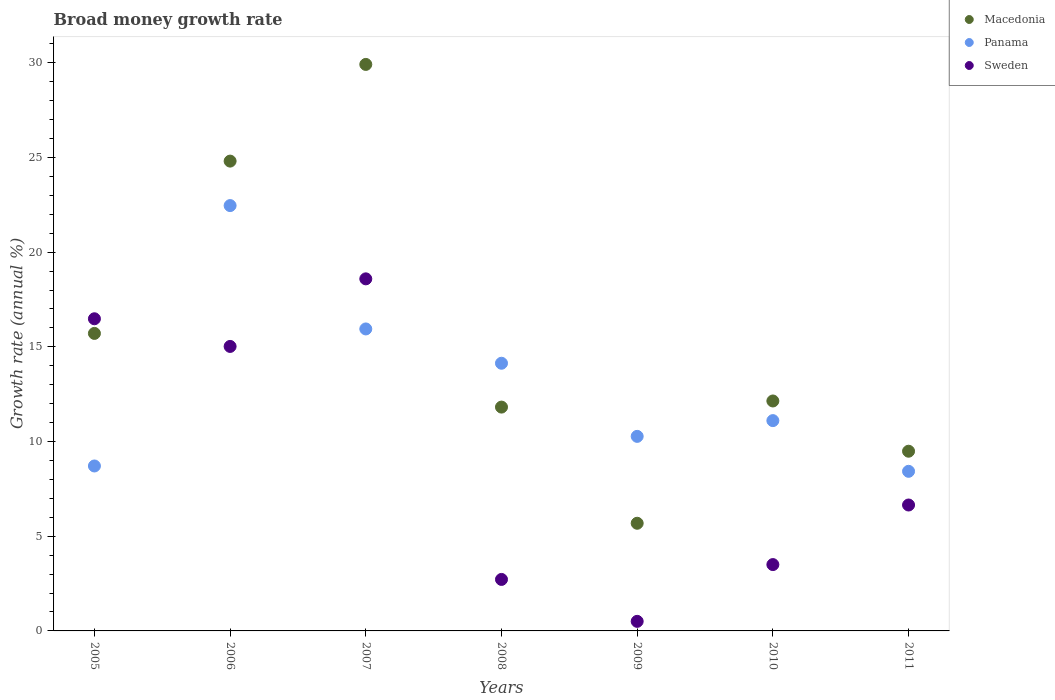How many different coloured dotlines are there?
Your response must be concise. 3. What is the growth rate in Panama in 2010?
Provide a succinct answer. 11.1. Across all years, what is the maximum growth rate in Macedonia?
Provide a succinct answer. 29.91. Across all years, what is the minimum growth rate in Sweden?
Offer a terse response. 0.51. In which year was the growth rate in Panama maximum?
Give a very brief answer. 2006. What is the total growth rate in Sweden in the graph?
Provide a succinct answer. 63.47. What is the difference between the growth rate in Sweden in 2005 and that in 2010?
Offer a very short reply. 12.98. What is the difference between the growth rate in Sweden in 2006 and the growth rate in Macedonia in 2010?
Offer a terse response. 2.88. What is the average growth rate in Macedonia per year?
Make the answer very short. 15.65. In the year 2008, what is the difference between the growth rate in Panama and growth rate in Macedonia?
Provide a succinct answer. 2.32. In how many years, is the growth rate in Panama greater than 5 %?
Ensure brevity in your answer.  7. What is the ratio of the growth rate in Sweden in 2005 to that in 2008?
Offer a terse response. 6.06. Is the difference between the growth rate in Panama in 2010 and 2011 greater than the difference between the growth rate in Macedonia in 2010 and 2011?
Your answer should be very brief. Yes. What is the difference between the highest and the second highest growth rate in Macedonia?
Ensure brevity in your answer.  5.11. What is the difference between the highest and the lowest growth rate in Sweden?
Offer a terse response. 18.08. In how many years, is the growth rate in Macedonia greater than the average growth rate in Macedonia taken over all years?
Your answer should be compact. 3. Is the sum of the growth rate in Panama in 2005 and 2011 greater than the maximum growth rate in Macedonia across all years?
Make the answer very short. No. Is the growth rate in Panama strictly less than the growth rate in Macedonia over the years?
Your answer should be very brief. No. What is the difference between two consecutive major ticks on the Y-axis?
Your response must be concise. 5. Are the values on the major ticks of Y-axis written in scientific E-notation?
Make the answer very short. No. Does the graph contain any zero values?
Keep it short and to the point. No. Does the graph contain grids?
Provide a succinct answer. No. What is the title of the graph?
Offer a terse response. Broad money growth rate. Does "Portugal" appear as one of the legend labels in the graph?
Your answer should be compact. No. What is the label or title of the X-axis?
Provide a succinct answer. Years. What is the label or title of the Y-axis?
Make the answer very short. Growth rate (annual %). What is the Growth rate (annual %) of Macedonia in 2005?
Keep it short and to the point. 15.71. What is the Growth rate (annual %) of Panama in 2005?
Ensure brevity in your answer.  8.71. What is the Growth rate (annual %) of Sweden in 2005?
Keep it short and to the point. 16.48. What is the Growth rate (annual %) of Macedonia in 2006?
Give a very brief answer. 24.81. What is the Growth rate (annual %) of Panama in 2006?
Offer a very short reply. 22.46. What is the Growth rate (annual %) of Sweden in 2006?
Make the answer very short. 15.02. What is the Growth rate (annual %) in Macedonia in 2007?
Offer a very short reply. 29.91. What is the Growth rate (annual %) of Panama in 2007?
Your answer should be compact. 15.95. What is the Growth rate (annual %) of Sweden in 2007?
Ensure brevity in your answer.  18.59. What is the Growth rate (annual %) of Macedonia in 2008?
Your answer should be compact. 11.82. What is the Growth rate (annual %) in Panama in 2008?
Offer a terse response. 14.13. What is the Growth rate (annual %) in Sweden in 2008?
Provide a short and direct response. 2.72. What is the Growth rate (annual %) in Macedonia in 2009?
Give a very brief answer. 5.68. What is the Growth rate (annual %) of Panama in 2009?
Offer a terse response. 10.27. What is the Growth rate (annual %) in Sweden in 2009?
Your answer should be compact. 0.51. What is the Growth rate (annual %) in Macedonia in 2010?
Offer a very short reply. 12.14. What is the Growth rate (annual %) of Panama in 2010?
Offer a very short reply. 11.1. What is the Growth rate (annual %) in Sweden in 2010?
Your answer should be compact. 3.5. What is the Growth rate (annual %) in Macedonia in 2011?
Ensure brevity in your answer.  9.49. What is the Growth rate (annual %) of Panama in 2011?
Provide a short and direct response. 8.43. What is the Growth rate (annual %) in Sweden in 2011?
Your response must be concise. 6.65. Across all years, what is the maximum Growth rate (annual %) of Macedonia?
Offer a very short reply. 29.91. Across all years, what is the maximum Growth rate (annual %) of Panama?
Keep it short and to the point. 22.46. Across all years, what is the maximum Growth rate (annual %) of Sweden?
Ensure brevity in your answer.  18.59. Across all years, what is the minimum Growth rate (annual %) in Macedonia?
Your answer should be compact. 5.68. Across all years, what is the minimum Growth rate (annual %) of Panama?
Your response must be concise. 8.43. Across all years, what is the minimum Growth rate (annual %) of Sweden?
Provide a succinct answer. 0.51. What is the total Growth rate (annual %) in Macedonia in the graph?
Your response must be concise. 109.56. What is the total Growth rate (annual %) of Panama in the graph?
Your response must be concise. 91.05. What is the total Growth rate (annual %) of Sweden in the graph?
Your response must be concise. 63.47. What is the difference between the Growth rate (annual %) of Macedonia in 2005 and that in 2006?
Ensure brevity in your answer.  -9.1. What is the difference between the Growth rate (annual %) of Panama in 2005 and that in 2006?
Give a very brief answer. -13.75. What is the difference between the Growth rate (annual %) in Sweden in 2005 and that in 2006?
Offer a terse response. 1.46. What is the difference between the Growth rate (annual %) in Macedonia in 2005 and that in 2007?
Provide a succinct answer. -14.2. What is the difference between the Growth rate (annual %) in Panama in 2005 and that in 2007?
Your answer should be compact. -7.24. What is the difference between the Growth rate (annual %) in Sweden in 2005 and that in 2007?
Provide a succinct answer. -2.11. What is the difference between the Growth rate (annual %) in Macedonia in 2005 and that in 2008?
Make the answer very short. 3.89. What is the difference between the Growth rate (annual %) of Panama in 2005 and that in 2008?
Offer a very short reply. -5.42. What is the difference between the Growth rate (annual %) in Sweden in 2005 and that in 2008?
Give a very brief answer. 13.76. What is the difference between the Growth rate (annual %) of Macedonia in 2005 and that in 2009?
Give a very brief answer. 10.02. What is the difference between the Growth rate (annual %) in Panama in 2005 and that in 2009?
Provide a succinct answer. -1.56. What is the difference between the Growth rate (annual %) in Sweden in 2005 and that in 2009?
Your answer should be very brief. 15.98. What is the difference between the Growth rate (annual %) of Macedonia in 2005 and that in 2010?
Make the answer very short. 3.57. What is the difference between the Growth rate (annual %) of Panama in 2005 and that in 2010?
Offer a terse response. -2.39. What is the difference between the Growth rate (annual %) of Sweden in 2005 and that in 2010?
Keep it short and to the point. 12.98. What is the difference between the Growth rate (annual %) in Macedonia in 2005 and that in 2011?
Your answer should be compact. 6.22. What is the difference between the Growth rate (annual %) in Panama in 2005 and that in 2011?
Provide a short and direct response. 0.28. What is the difference between the Growth rate (annual %) in Sweden in 2005 and that in 2011?
Make the answer very short. 9.83. What is the difference between the Growth rate (annual %) of Macedonia in 2006 and that in 2007?
Your answer should be very brief. -5.11. What is the difference between the Growth rate (annual %) in Panama in 2006 and that in 2007?
Your response must be concise. 6.51. What is the difference between the Growth rate (annual %) of Sweden in 2006 and that in 2007?
Provide a succinct answer. -3.57. What is the difference between the Growth rate (annual %) in Macedonia in 2006 and that in 2008?
Your answer should be compact. 12.99. What is the difference between the Growth rate (annual %) of Panama in 2006 and that in 2008?
Offer a very short reply. 8.32. What is the difference between the Growth rate (annual %) in Sweden in 2006 and that in 2008?
Your answer should be very brief. 12.3. What is the difference between the Growth rate (annual %) of Macedonia in 2006 and that in 2009?
Keep it short and to the point. 19.12. What is the difference between the Growth rate (annual %) of Panama in 2006 and that in 2009?
Provide a short and direct response. 12.19. What is the difference between the Growth rate (annual %) of Sweden in 2006 and that in 2009?
Your answer should be compact. 14.52. What is the difference between the Growth rate (annual %) in Macedonia in 2006 and that in 2010?
Your answer should be compact. 12.67. What is the difference between the Growth rate (annual %) in Panama in 2006 and that in 2010?
Keep it short and to the point. 11.35. What is the difference between the Growth rate (annual %) of Sweden in 2006 and that in 2010?
Your answer should be compact. 11.52. What is the difference between the Growth rate (annual %) in Macedonia in 2006 and that in 2011?
Your response must be concise. 15.32. What is the difference between the Growth rate (annual %) in Panama in 2006 and that in 2011?
Your answer should be very brief. 14.03. What is the difference between the Growth rate (annual %) of Sweden in 2006 and that in 2011?
Make the answer very short. 8.37. What is the difference between the Growth rate (annual %) of Macedonia in 2007 and that in 2008?
Provide a succinct answer. 18.09. What is the difference between the Growth rate (annual %) in Panama in 2007 and that in 2008?
Provide a short and direct response. 1.81. What is the difference between the Growth rate (annual %) in Sweden in 2007 and that in 2008?
Make the answer very short. 15.87. What is the difference between the Growth rate (annual %) of Macedonia in 2007 and that in 2009?
Your answer should be compact. 24.23. What is the difference between the Growth rate (annual %) in Panama in 2007 and that in 2009?
Provide a short and direct response. 5.67. What is the difference between the Growth rate (annual %) of Sweden in 2007 and that in 2009?
Make the answer very short. 18.08. What is the difference between the Growth rate (annual %) of Macedonia in 2007 and that in 2010?
Your response must be concise. 17.77. What is the difference between the Growth rate (annual %) in Panama in 2007 and that in 2010?
Give a very brief answer. 4.84. What is the difference between the Growth rate (annual %) of Sweden in 2007 and that in 2010?
Ensure brevity in your answer.  15.09. What is the difference between the Growth rate (annual %) in Macedonia in 2007 and that in 2011?
Give a very brief answer. 20.42. What is the difference between the Growth rate (annual %) of Panama in 2007 and that in 2011?
Make the answer very short. 7.52. What is the difference between the Growth rate (annual %) in Sweden in 2007 and that in 2011?
Your answer should be very brief. 11.94. What is the difference between the Growth rate (annual %) of Macedonia in 2008 and that in 2009?
Ensure brevity in your answer.  6.13. What is the difference between the Growth rate (annual %) of Panama in 2008 and that in 2009?
Your response must be concise. 3.86. What is the difference between the Growth rate (annual %) in Sweden in 2008 and that in 2009?
Offer a very short reply. 2.21. What is the difference between the Growth rate (annual %) of Macedonia in 2008 and that in 2010?
Your answer should be very brief. -0.32. What is the difference between the Growth rate (annual %) in Panama in 2008 and that in 2010?
Offer a very short reply. 3.03. What is the difference between the Growth rate (annual %) of Sweden in 2008 and that in 2010?
Offer a terse response. -0.78. What is the difference between the Growth rate (annual %) in Macedonia in 2008 and that in 2011?
Provide a succinct answer. 2.33. What is the difference between the Growth rate (annual %) of Panama in 2008 and that in 2011?
Make the answer very short. 5.71. What is the difference between the Growth rate (annual %) of Sweden in 2008 and that in 2011?
Your answer should be compact. -3.93. What is the difference between the Growth rate (annual %) in Macedonia in 2009 and that in 2010?
Ensure brevity in your answer.  -6.46. What is the difference between the Growth rate (annual %) in Panama in 2009 and that in 2010?
Offer a terse response. -0.83. What is the difference between the Growth rate (annual %) of Sweden in 2009 and that in 2010?
Offer a terse response. -3. What is the difference between the Growth rate (annual %) in Macedonia in 2009 and that in 2011?
Your response must be concise. -3.8. What is the difference between the Growth rate (annual %) of Panama in 2009 and that in 2011?
Offer a terse response. 1.85. What is the difference between the Growth rate (annual %) in Sweden in 2009 and that in 2011?
Ensure brevity in your answer.  -6.14. What is the difference between the Growth rate (annual %) in Macedonia in 2010 and that in 2011?
Your answer should be compact. 2.65. What is the difference between the Growth rate (annual %) of Panama in 2010 and that in 2011?
Offer a terse response. 2.68. What is the difference between the Growth rate (annual %) in Sweden in 2010 and that in 2011?
Offer a very short reply. -3.15. What is the difference between the Growth rate (annual %) in Macedonia in 2005 and the Growth rate (annual %) in Panama in 2006?
Make the answer very short. -6.75. What is the difference between the Growth rate (annual %) in Macedonia in 2005 and the Growth rate (annual %) in Sweden in 2006?
Offer a very short reply. 0.69. What is the difference between the Growth rate (annual %) in Panama in 2005 and the Growth rate (annual %) in Sweden in 2006?
Offer a terse response. -6.31. What is the difference between the Growth rate (annual %) in Macedonia in 2005 and the Growth rate (annual %) in Panama in 2007?
Provide a short and direct response. -0.24. What is the difference between the Growth rate (annual %) of Macedonia in 2005 and the Growth rate (annual %) of Sweden in 2007?
Your answer should be compact. -2.88. What is the difference between the Growth rate (annual %) of Panama in 2005 and the Growth rate (annual %) of Sweden in 2007?
Offer a very short reply. -9.88. What is the difference between the Growth rate (annual %) of Macedonia in 2005 and the Growth rate (annual %) of Panama in 2008?
Your answer should be compact. 1.57. What is the difference between the Growth rate (annual %) of Macedonia in 2005 and the Growth rate (annual %) of Sweden in 2008?
Make the answer very short. 12.99. What is the difference between the Growth rate (annual %) of Panama in 2005 and the Growth rate (annual %) of Sweden in 2008?
Keep it short and to the point. 5.99. What is the difference between the Growth rate (annual %) of Macedonia in 2005 and the Growth rate (annual %) of Panama in 2009?
Your answer should be very brief. 5.44. What is the difference between the Growth rate (annual %) of Macedonia in 2005 and the Growth rate (annual %) of Sweden in 2009?
Your answer should be very brief. 15.2. What is the difference between the Growth rate (annual %) in Panama in 2005 and the Growth rate (annual %) in Sweden in 2009?
Provide a short and direct response. 8.2. What is the difference between the Growth rate (annual %) in Macedonia in 2005 and the Growth rate (annual %) in Panama in 2010?
Your response must be concise. 4.6. What is the difference between the Growth rate (annual %) of Macedonia in 2005 and the Growth rate (annual %) of Sweden in 2010?
Provide a short and direct response. 12.21. What is the difference between the Growth rate (annual %) of Panama in 2005 and the Growth rate (annual %) of Sweden in 2010?
Make the answer very short. 5.21. What is the difference between the Growth rate (annual %) in Macedonia in 2005 and the Growth rate (annual %) in Panama in 2011?
Give a very brief answer. 7.28. What is the difference between the Growth rate (annual %) in Macedonia in 2005 and the Growth rate (annual %) in Sweden in 2011?
Your answer should be very brief. 9.06. What is the difference between the Growth rate (annual %) of Panama in 2005 and the Growth rate (annual %) of Sweden in 2011?
Ensure brevity in your answer.  2.06. What is the difference between the Growth rate (annual %) in Macedonia in 2006 and the Growth rate (annual %) in Panama in 2007?
Offer a very short reply. 8.86. What is the difference between the Growth rate (annual %) of Macedonia in 2006 and the Growth rate (annual %) of Sweden in 2007?
Give a very brief answer. 6.22. What is the difference between the Growth rate (annual %) in Panama in 2006 and the Growth rate (annual %) in Sweden in 2007?
Give a very brief answer. 3.87. What is the difference between the Growth rate (annual %) in Macedonia in 2006 and the Growth rate (annual %) in Panama in 2008?
Offer a very short reply. 10.67. What is the difference between the Growth rate (annual %) in Macedonia in 2006 and the Growth rate (annual %) in Sweden in 2008?
Make the answer very short. 22.09. What is the difference between the Growth rate (annual %) of Panama in 2006 and the Growth rate (annual %) of Sweden in 2008?
Ensure brevity in your answer.  19.74. What is the difference between the Growth rate (annual %) of Macedonia in 2006 and the Growth rate (annual %) of Panama in 2009?
Provide a short and direct response. 14.53. What is the difference between the Growth rate (annual %) of Macedonia in 2006 and the Growth rate (annual %) of Sweden in 2009?
Give a very brief answer. 24.3. What is the difference between the Growth rate (annual %) of Panama in 2006 and the Growth rate (annual %) of Sweden in 2009?
Make the answer very short. 21.95. What is the difference between the Growth rate (annual %) in Macedonia in 2006 and the Growth rate (annual %) in Panama in 2010?
Your answer should be very brief. 13.7. What is the difference between the Growth rate (annual %) in Macedonia in 2006 and the Growth rate (annual %) in Sweden in 2010?
Your response must be concise. 21.3. What is the difference between the Growth rate (annual %) of Panama in 2006 and the Growth rate (annual %) of Sweden in 2010?
Your answer should be very brief. 18.96. What is the difference between the Growth rate (annual %) in Macedonia in 2006 and the Growth rate (annual %) in Panama in 2011?
Provide a short and direct response. 16.38. What is the difference between the Growth rate (annual %) in Macedonia in 2006 and the Growth rate (annual %) in Sweden in 2011?
Make the answer very short. 18.16. What is the difference between the Growth rate (annual %) in Panama in 2006 and the Growth rate (annual %) in Sweden in 2011?
Offer a terse response. 15.81. What is the difference between the Growth rate (annual %) of Macedonia in 2007 and the Growth rate (annual %) of Panama in 2008?
Provide a short and direct response. 15.78. What is the difference between the Growth rate (annual %) in Macedonia in 2007 and the Growth rate (annual %) in Sweden in 2008?
Keep it short and to the point. 27.19. What is the difference between the Growth rate (annual %) in Panama in 2007 and the Growth rate (annual %) in Sweden in 2008?
Offer a terse response. 13.23. What is the difference between the Growth rate (annual %) of Macedonia in 2007 and the Growth rate (annual %) of Panama in 2009?
Make the answer very short. 19.64. What is the difference between the Growth rate (annual %) in Macedonia in 2007 and the Growth rate (annual %) in Sweden in 2009?
Your answer should be very brief. 29.41. What is the difference between the Growth rate (annual %) of Panama in 2007 and the Growth rate (annual %) of Sweden in 2009?
Provide a short and direct response. 15.44. What is the difference between the Growth rate (annual %) in Macedonia in 2007 and the Growth rate (annual %) in Panama in 2010?
Provide a short and direct response. 18.81. What is the difference between the Growth rate (annual %) in Macedonia in 2007 and the Growth rate (annual %) in Sweden in 2010?
Provide a short and direct response. 26.41. What is the difference between the Growth rate (annual %) of Panama in 2007 and the Growth rate (annual %) of Sweden in 2010?
Make the answer very short. 12.44. What is the difference between the Growth rate (annual %) of Macedonia in 2007 and the Growth rate (annual %) of Panama in 2011?
Your response must be concise. 21.48. What is the difference between the Growth rate (annual %) in Macedonia in 2007 and the Growth rate (annual %) in Sweden in 2011?
Offer a very short reply. 23.26. What is the difference between the Growth rate (annual %) in Panama in 2007 and the Growth rate (annual %) in Sweden in 2011?
Keep it short and to the point. 9.3. What is the difference between the Growth rate (annual %) in Macedonia in 2008 and the Growth rate (annual %) in Panama in 2009?
Give a very brief answer. 1.55. What is the difference between the Growth rate (annual %) of Macedonia in 2008 and the Growth rate (annual %) of Sweden in 2009?
Ensure brevity in your answer.  11.31. What is the difference between the Growth rate (annual %) of Panama in 2008 and the Growth rate (annual %) of Sweden in 2009?
Give a very brief answer. 13.63. What is the difference between the Growth rate (annual %) in Macedonia in 2008 and the Growth rate (annual %) in Panama in 2010?
Make the answer very short. 0.71. What is the difference between the Growth rate (annual %) in Macedonia in 2008 and the Growth rate (annual %) in Sweden in 2010?
Ensure brevity in your answer.  8.32. What is the difference between the Growth rate (annual %) in Panama in 2008 and the Growth rate (annual %) in Sweden in 2010?
Provide a succinct answer. 10.63. What is the difference between the Growth rate (annual %) in Macedonia in 2008 and the Growth rate (annual %) in Panama in 2011?
Ensure brevity in your answer.  3.39. What is the difference between the Growth rate (annual %) in Macedonia in 2008 and the Growth rate (annual %) in Sweden in 2011?
Provide a succinct answer. 5.17. What is the difference between the Growth rate (annual %) in Panama in 2008 and the Growth rate (annual %) in Sweden in 2011?
Keep it short and to the point. 7.49. What is the difference between the Growth rate (annual %) in Macedonia in 2009 and the Growth rate (annual %) in Panama in 2010?
Your answer should be very brief. -5.42. What is the difference between the Growth rate (annual %) in Macedonia in 2009 and the Growth rate (annual %) in Sweden in 2010?
Offer a terse response. 2.18. What is the difference between the Growth rate (annual %) of Panama in 2009 and the Growth rate (annual %) of Sweden in 2010?
Your response must be concise. 6.77. What is the difference between the Growth rate (annual %) in Macedonia in 2009 and the Growth rate (annual %) in Panama in 2011?
Your answer should be very brief. -2.74. What is the difference between the Growth rate (annual %) of Macedonia in 2009 and the Growth rate (annual %) of Sweden in 2011?
Keep it short and to the point. -0.96. What is the difference between the Growth rate (annual %) of Panama in 2009 and the Growth rate (annual %) of Sweden in 2011?
Give a very brief answer. 3.62. What is the difference between the Growth rate (annual %) in Macedonia in 2010 and the Growth rate (annual %) in Panama in 2011?
Ensure brevity in your answer.  3.71. What is the difference between the Growth rate (annual %) of Macedonia in 2010 and the Growth rate (annual %) of Sweden in 2011?
Your response must be concise. 5.49. What is the difference between the Growth rate (annual %) in Panama in 2010 and the Growth rate (annual %) in Sweden in 2011?
Keep it short and to the point. 4.46. What is the average Growth rate (annual %) of Macedonia per year?
Make the answer very short. 15.65. What is the average Growth rate (annual %) of Panama per year?
Your answer should be very brief. 13.01. What is the average Growth rate (annual %) in Sweden per year?
Keep it short and to the point. 9.07. In the year 2005, what is the difference between the Growth rate (annual %) in Macedonia and Growth rate (annual %) in Panama?
Keep it short and to the point. 7. In the year 2005, what is the difference between the Growth rate (annual %) in Macedonia and Growth rate (annual %) in Sweden?
Your answer should be compact. -0.77. In the year 2005, what is the difference between the Growth rate (annual %) in Panama and Growth rate (annual %) in Sweden?
Provide a succinct answer. -7.77. In the year 2006, what is the difference between the Growth rate (annual %) in Macedonia and Growth rate (annual %) in Panama?
Provide a succinct answer. 2.35. In the year 2006, what is the difference between the Growth rate (annual %) in Macedonia and Growth rate (annual %) in Sweden?
Ensure brevity in your answer.  9.79. In the year 2006, what is the difference between the Growth rate (annual %) in Panama and Growth rate (annual %) in Sweden?
Offer a terse response. 7.44. In the year 2007, what is the difference between the Growth rate (annual %) of Macedonia and Growth rate (annual %) of Panama?
Ensure brevity in your answer.  13.97. In the year 2007, what is the difference between the Growth rate (annual %) of Macedonia and Growth rate (annual %) of Sweden?
Offer a very short reply. 11.32. In the year 2007, what is the difference between the Growth rate (annual %) in Panama and Growth rate (annual %) in Sweden?
Provide a succinct answer. -2.64. In the year 2008, what is the difference between the Growth rate (annual %) in Macedonia and Growth rate (annual %) in Panama?
Your answer should be compact. -2.32. In the year 2008, what is the difference between the Growth rate (annual %) of Macedonia and Growth rate (annual %) of Sweden?
Give a very brief answer. 9.1. In the year 2008, what is the difference between the Growth rate (annual %) of Panama and Growth rate (annual %) of Sweden?
Keep it short and to the point. 11.41. In the year 2009, what is the difference between the Growth rate (annual %) in Macedonia and Growth rate (annual %) in Panama?
Your answer should be very brief. -4.59. In the year 2009, what is the difference between the Growth rate (annual %) in Macedonia and Growth rate (annual %) in Sweden?
Your answer should be very brief. 5.18. In the year 2009, what is the difference between the Growth rate (annual %) of Panama and Growth rate (annual %) of Sweden?
Your answer should be compact. 9.77. In the year 2010, what is the difference between the Growth rate (annual %) in Macedonia and Growth rate (annual %) in Panama?
Your response must be concise. 1.04. In the year 2010, what is the difference between the Growth rate (annual %) of Macedonia and Growth rate (annual %) of Sweden?
Make the answer very short. 8.64. In the year 2010, what is the difference between the Growth rate (annual %) of Panama and Growth rate (annual %) of Sweden?
Make the answer very short. 7.6. In the year 2011, what is the difference between the Growth rate (annual %) in Macedonia and Growth rate (annual %) in Panama?
Ensure brevity in your answer.  1.06. In the year 2011, what is the difference between the Growth rate (annual %) in Macedonia and Growth rate (annual %) in Sweden?
Offer a terse response. 2.84. In the year 2011, what is the difference between the Growth rate (annual %) of Panama and Growth rate (annual %) of Sweden?
Your response must be concise. 1.78. What is the ratio of the Growth rate (annual %) in Macedonia in 2005 to that in 2006?
Provide a succinct answer. 0.63. What is the ratio of the Growth rate (annual %) in Panama in 2005 to that in 2006?
Give a very brief answer. 0.39. What is the ratio of the Growth rate (annual %) of Sweden in 2005 to that in 2006?
Your answer should be very brief. 1.1. What is the ratio of the Growth rate (annual %) of Macedonia in 2005 to that in 2007?
Offer a terse response. 0.53. What is the ratio of the Growth rate (annual %) in Panama in 2005 to that in 2007?
Provide a succinct answer. 0.55. What is the ratio of the Growth rate (annual %) of Sweden in 2005 to that in 2007?
Provide a succinct answer. 0.89. What is the ratio of the Growth rate (annual %) of Macedonia in 2005 to that in 2008?
Your answer should be compact. 1.33. What is the ratio of the Growth rate (annual %) in Panama in 2005 to that in 2008?
Provide a short and direct response. 0.62. What is the ratio of the Growth rate (annual %) of Sweden in 2005 to that in 2008?
Your response must be concise. 6.06. What is the ratio of the Growth rate (annual %) in Macedonia in 2005 to that in 2009?
Provide a short and direct response. 2.76. What is the ratio of the Growth rate (annual %) of Panama in 2005 to that in 2009?
Make the answer very short. 0.85. What is the ratio of the Growth rate (annual %) of Sweden in 2005 to that in 2009?
Your answer should be compact. 32.63. What is the ratio of the Growth rate (annual %) of Macedonia in 2005 to that in 2010?
Offer a terse response. 1.29. What is the ratio of the Growth rate (annual %) of Panama in 2005 to that in 2010?
Your answer should be compact. 0.78. What is the ratio of the Growth rate (annual %) of Sweden in 2005 to that in 2010?
Your answer should be compact. 4.71. What is the ratio of the Growth rate (annual %) in Macedonia in 2005 to that in 2011?
Offer a very short reply. 1.66. What is the ratio of the Growth rate (annual %) in Panama in 2005 to that in 2011?
Provide a short and direct response. 1.03. What is the ratio of the Growth rate (annual %) of Sweden in 2005 to that in 2011?
Your answer should be very brief. 2.48. What is the ratio of the Growth rate (annual %) of Macedonia in 2006 to that in 2007?
Your answer should be compact. 0.83. What is the ratio of the Growth rate (annual %) of Panama in 2006 to that in 2007?
Your answer should be compact. 1.41. What is the ratio of the Growth rate (annual %) in Sweden in 2006 to that in 2007?
Your answer should be very brief. 0.81. What is the ratio of the Growth rate (annual %) of Macedonia in 2006 to that in 2008?
Your answer should be very brief. 2.1. What is the ratio of the Growth rate (annual %) in Panama in 2006 to that in 2008?
Offer a terse response. 1.59. What is the ratio of the Growth rate (annual %) of Sweden in 2006 to that in 2008?
Ensure brevity in your answer.  5.52. What is the ratio of the Growth rate (annual %) of Macedonia in 2006 to that in 2009?
Offer a very short reply. 4.36. What is the ratio of the Growth rate (annual %) of Panama in 2006 to that in 2009?
Keep it short and to the point. 2.19. What is the ratio of the Growth rate (annual %) in Sweden in 2006 to that in 2009?
Offer a terse response. 29.74. What is the ratio of the Growth rate (annual %) of Macedonia in 2006 to that in 2010?
Ensure brevity in your answer.  2.04. What is the ratio of the Growth rate (annual %) of Panama in 2006 to that in 2010?
Your response must be concise. 2.02. What is the ratio of the Growth rate (annual %) of Sweden in 2006 to that in 2010?
Your answer should be very brief. 4.29. What is the ratio of the Growth rate (annual %) of Macedonia in 2006 to that in 2011?
Your answer should be very brief. 2.61. What is the ratio of the Growth rate (annual %) of Panama in 2006 to that in 2011?
Your answer should be compact. 2.66. What is the ratio of the Growth rate (annual %) of Sweden in 2006 to that in 2011?
Provide a succinct answer. 2.26. What is the ratio of the Growth rate (annual %) in Macedonia in 2007 to that in 2008?
Provide a succinct answer. 2.53. What is the ratio of the Growth rate (annual %) of Panama in 2007 to that in 2008?
Your response must be concise. 1.13. What is the ratio of the Growth rate (annual %) in Sweden in 2007 to that in 2008?
Ensure brevity in your answer.  6.84. What is the ratio of the Growth rate (annual %) in Macedonia in 2007 to that in 2009?
Your answer should be very brief. 5.26. What is the ratio of the Growth rate (annual %) of Panama in 2007 to that in 2009?
Provide a succinct answer. 1.55. What is the ratio of the Growth rate (annual %) of Sweden in 2007 to that in 2009?
Provide a succinct answer. 36.8. What is the ratio of the Growth rate (annual %) of Macedonia in 2007 to that in 2010?
Your answer should be compact. 2.46. What is the ratio of the Growth rate (annual %) of Panama in 2007 to that in 2010?
Your answer should be compact. 1.44. What is the ratio of the Growth rate (annual %) of Sweden in 2007 to that in 2010?
Your response must be concise. 5.31. What is the ratio of the Growth rate (annual %) in Macedonia in 2007 to that in 2011?
Your answer should be very brief. 3.15. What is the ratio of the Growth rate (annual %) of Panama in 2007 to that in 2011?
Keep it short and to the point. 1.89. What is the ratio of the Growth rate (annual %) of Sweden in 2007 to that in 2011?
Your response must be concise. 2.8. What is the ratio of the Growth rate (annual %) in Macedonia in 2008 to that in 2009?
Your response must be concise. 2.08. What is the ratio of the Growth rate (annual %) of Panama in 2008 to that in 2009?
Provide a short and direct response. 1.38. What is the ratio of the Growth rate (annual %) in Sweden in 2008 to that in 2009?
Your answer should be very brief. 5.38. What is the ratio of the Growth rate (annual %) in Macedonia in 2008 to that in 2010?
Keep it short and to the point. 0.97. What is the ratio of the Growth rate (annual %) of Panama in 2008 to that in 2010?
Make the answer very short. 1.27. What is the ratio of the Growth rate (annual %) of Sweden in 2008 to that in 2010?
Make the answer very short. 0.78. What is the ratio of the Growth rate (annual %) of Macedonia in 2008 to that in 2011?
Provide a short and direct response. 1.25. What is the ratio of the Growth rate (annual %) in Panama in 2008 to that in 2011?
Give a very brief answer. 1.68. What is the ratio of the Growth rate (annual %) of Sweden in 2008 to that in 2011?
Offer a terse response. 0.41. What is the ratio of the Growth rate (annual %) of Macedonia in 2009 to that in 2010?
Provide a succinct answer. 0.47. What is the ratio of the Growth rate (annual %) of Panama in 2009 to that in 2010?
Your response must be concise. 0.93. What is the ratio of the Growth rate (annual %) of Sweden in 2009 to that in 2010?
Your answer should be very brief. 0.14. What is the ratio of the Growth rate (annual %) of Macedonia in 2009 to that in 2011?
Ensure brevity in your answer.  0.6. What is the ratio of the Growth rate (annual %) of Panama in 2009 to that in 2011?
Give a very brief answer. 1.22. What is the ratio of the Growth rate (annual %) in Sweden in 2009 to that in 2011?
Your response must be concise. 0.08. What is the ratio of the Growth rate (annual %) in Macedonia in 2010 to that in 2011?
Provide a succinct answer. 1.28. What is the ratio of the Growth rate (annual %) in Panama in 2010 to that in 2011?
Your answer should be very brief. 1.32. What is the ratio of the Growth rate (annual %) in Sweden in 2010 to that in 2011?
Your response must be concise. 0.53. What is the difference between the highest and the second highest Growth rate (annual %) of Macedonia?
Make the answer very short. 5.11. What is the difference between the highest and the second highest Growth rate (annual %) of Panama?
Offer a terse response. 6.51. What is the difference between the highest and the second highest Growth rate (annual %) of Sweden?
Keep it short and to the point. 2.11. What is the difference between the highest and the lowest Growth rate (annual %) of Macedonia?
Your response must be concise. 24.23. What is the difference between the highest and the lowest Growth rate (annual %) of Panama?
Offer a terse response. 14.03. What is the difference between the highest and the lowest Growth rate (annual %) of Sweden?
Offer a very short reply. 18.08. 